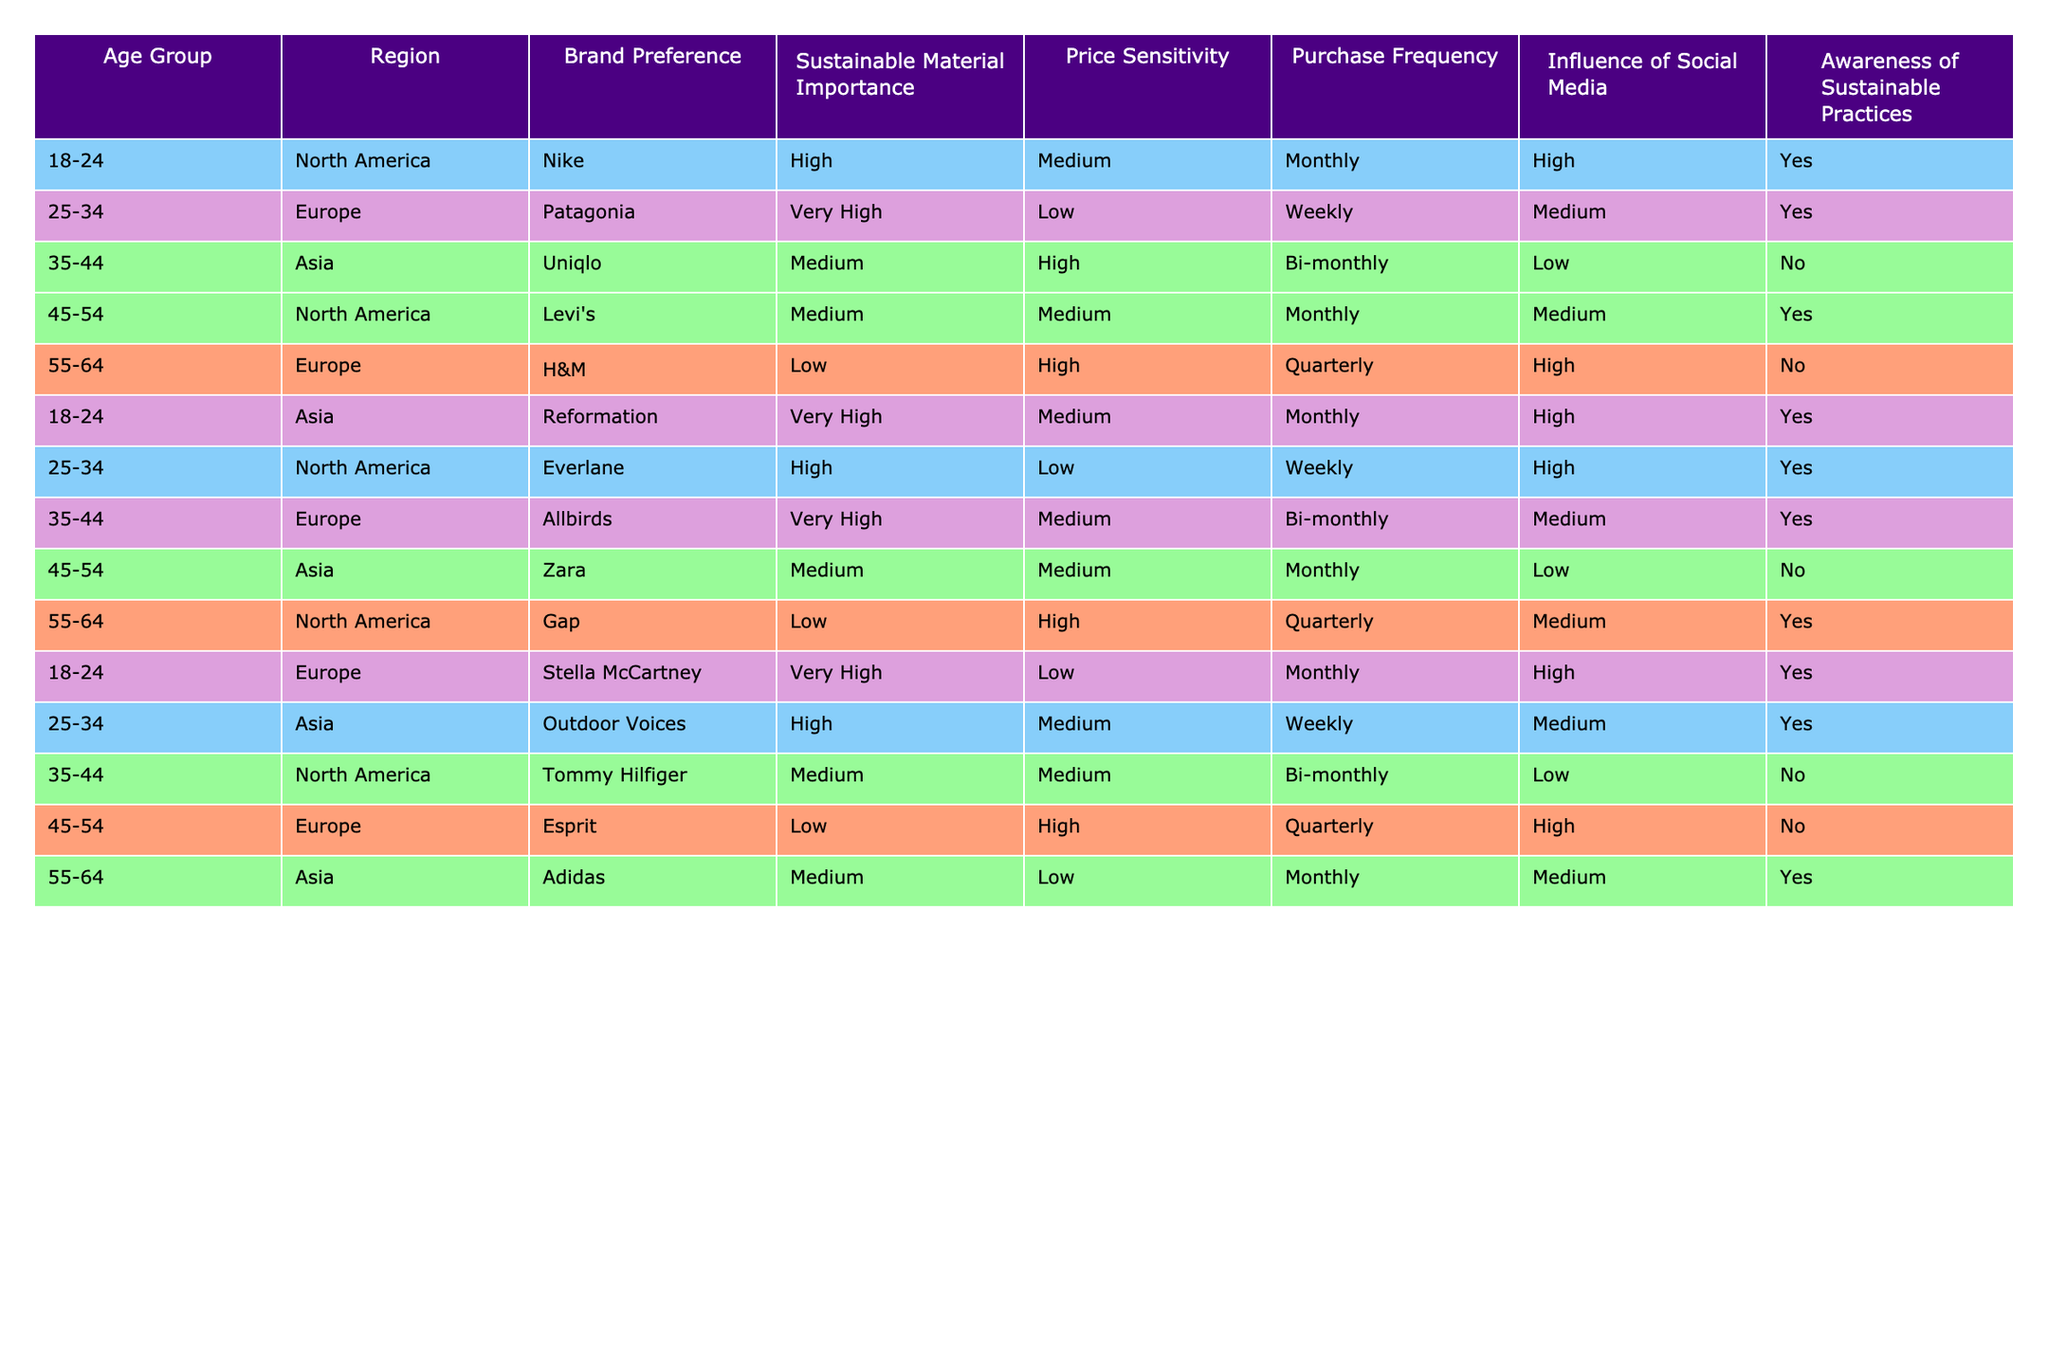What is the brand preference of consumers aged 25-34 in Europe? In the table, for the age group 25-34 in Europe, the brand preference listed is Patagonia.
Answer: Patagonia How often do consumers aged 55-64 in North America make purchases? According to the table, consumers aged 55-64 in North America have a purchase frequency of quarterly.
Answer: Quarterly Which region has the highest emphasis on sustainable material among the 18-24 age group? For the 18-24 age group, both North America and Asia indicate a very high importance of sustainable material, but Asia has a higher brand preference (Reformation). Therefore, Asia has the highest emphasis overall.
Answer: Asia What percentage of consumers in the age group 35-44 prefer brands that consider sustainability highly? In the age group 35-44, two brands (Allbirds and Uniqlo) are indicated. Allbirds is labeled as very high while Uniqlo is medium. Out of 5 total, this is 1 out of 3 brands preferred that have high sustainable importance, thus making it 33.33%.
Answer: 33.33% Is social media highly influential for consumers aged 45-54 in Europe? The table states that the influence of social media for consumers aged 45-54 in Europe is medium, not high.
Answer: No Which age group shows a notable preference for H&M and what is their region? The table shows that consumers aged 55-64 in Europe specifically prefer H&M.
Answer: 55-64, Europe What is the average sustainable material importance score for consumers aged 18-24 across all regions? The sustainable material importance score for 18-24 consumers is very high (Reformation and Stella McCartney) and high (Nike). Therefore, 6 (for 2 Very High) + 3 (for 1 High) / 3 = 4.33 is the average.
Answer: 4.33 Do consumers in Asia show awareness of sustainable practices? For consumers in Asia, the table indicates that individuals aged 35-44 and 45-54 do not have awareness, whereas those aged 18-24 and 25-34 do, thus it varies within the group but not all show it.
Answer: No How does price sensitivity vary between the region of North America and Asia for the 25-34 age group? In North America, the price sensitivity is low for Everlane, while in Asia it is medium for Outdoor Voices. This shows that in comparison North America is more price sensitive than Asia for that age group.
Answer: North America is more sensitive 